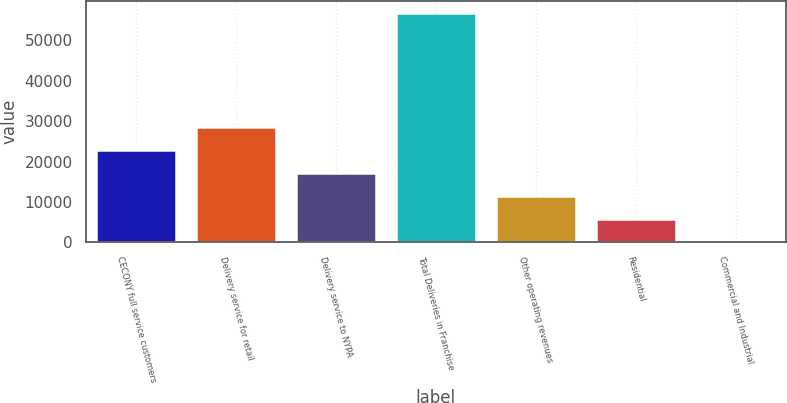Convert chart. <chart><loc_0><loc_0><loc_500><loc_500><bar_chart><fcel>CECONY full service customers<fcel>Delivery service for retail<fcel>Delivery service to NYPA<fcel>Total Deliveries in Franchise<fcel>Other operating revenues<fcel>Residential<fcel>Commercial and Industrial<nl><fcel>22779.6<fcel>28469.3<fcel>17089.8<fcel>56918<fcel>11400.1<fcel>5710.34<fcel>20.6<nl></chart> 